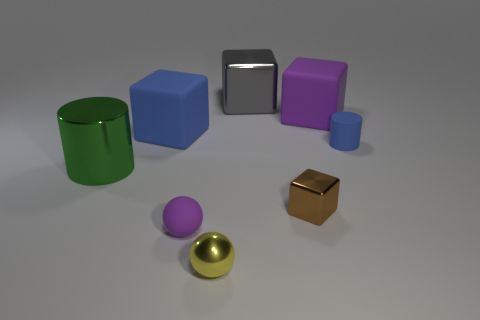Add 1 small blue metal cylinders. How many objects exist? 9 Subtract all purple matte cubes. How many cubes are left? 3 Subtract all purple cubes. How many cubes are left? 3 Subtract 0 yellow blocks. How many objects are left? 8 Subtract 2 blocks. How many blocks are left? 2 Subtract all gray cylinders. Subtract all red cubes. How many cylinders are left? 2 Subtract all brown balls. How many red cubes are left? 0 Subtract all cyan rubber objects. Subtract all large blue matte objects. How many objects are left? 7 Add 7 gray shiny blocks. How many gray shiny blocks are left? 8 Add 1 cyan metal cylinders. How many cyan metal cylinders exist? 1 